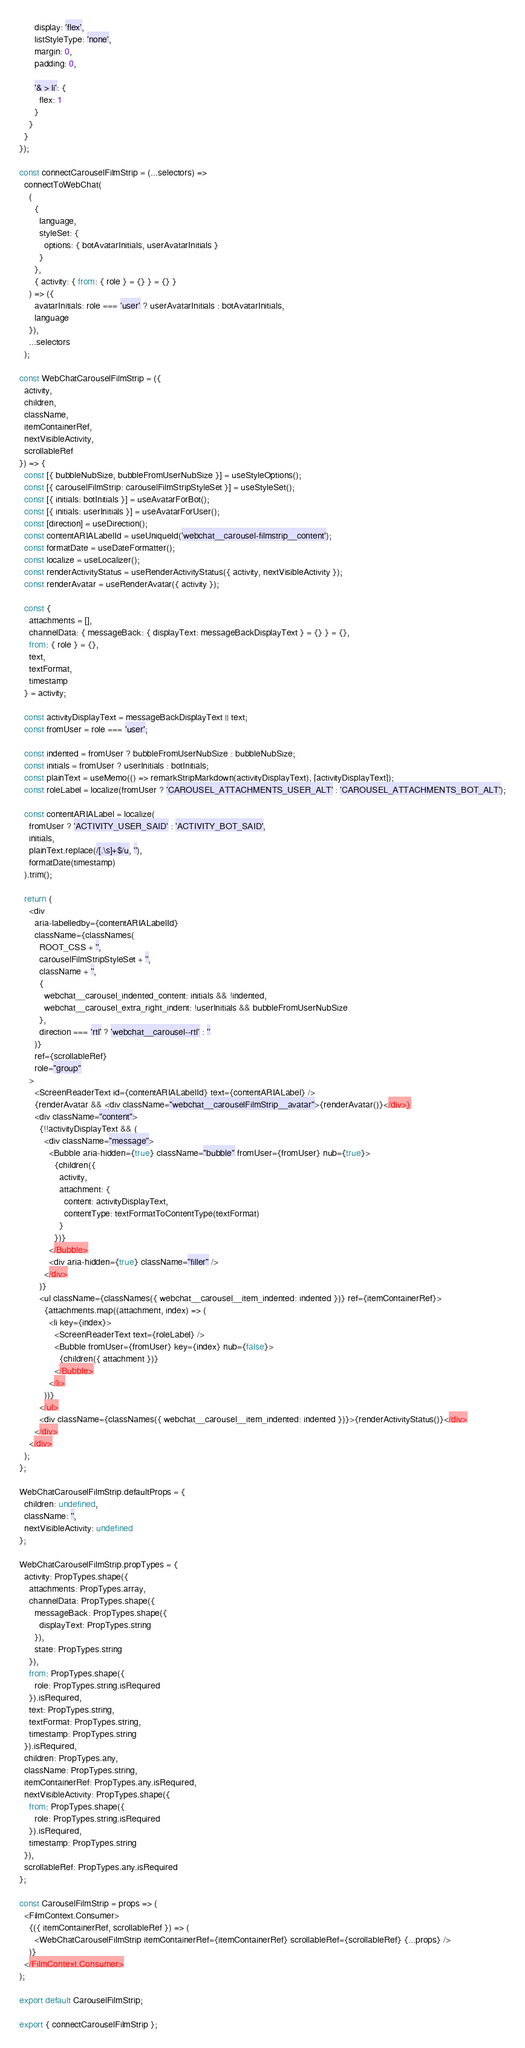<code> <loc_0><loc_0><loc_500><loc_500><_JavaScript_>      display: 'flex',
      listStyleType: 'none',
      margin: 0,
      padding: 0,

      '& > li': {
        flex: 1
      }
    }
  }
});

const connectCarouselFilmStrip = (...selectors) =>
  connectToWebChat(
    (
      {
        language,
        styleSet: {
          options: { botAvatarInitials, userAvatarInitials }
        }
      },
      { activity: { from: { role } = {} } = {} }
    ) => ({
      avatarInitials: role === 'user' ? userAvatarInitials : botAvatarInitials,
      language
    }),
    ...selectors
  );

const WebChatCarouselFilmStrip = ({
  activity,
  children,
  className,
  itemContainerRef,
  nextVisibleActivity,
  scrollableRef
}) => {
  const [{ bubbleNubSize, bubbleFromUserNubSize }] = useStyleOptions();
  const [{ carouselFilmStrip: carouselFilmStripStyleSet }] = useStyleSet();
  const [{ initials: botInitials }] = useAvatarForBot();
  const [{ initials: userInitials }] = useAvatarForUser();
  const [direction] = useDirection();
  const contentARIALabelId = useUniqueId('webchat__carousel-filmstrip__content');
  const formatDate = useDateFormatter();
  const localize = useLocalizer();
  const renderActivityStatus = useRenderActivityStatus({ activity, nextVisibleActivity });
  const renderAvatar = useRenderAvatar({ activity });

  const {
    attachments = [],
    channelData: { messageBack: { displayText: messageBackDisplayText } = {} } = {},
    from: { role } = {},
    text,
    textFormat,
    timestamp
  } = activity;

  const activityDisplayText = messageBackDisplayText || text;
  const fromUser = role === 'user';

  const indented = fromUser ? bubbleFromUserNubSize : bubbleNubSize;
  const initials = fromUser ? userInitials : botInitials;
  const plainText = useMemo(() => remarkStripMarkdown(activityDisplayText), [activityDisplayText]);
  const roleLabel = localize(fromUser ? 'CAROUSEL_ATTACHMENTS_USER_ALT' : 'CAROUSEL_ATTACHMENTS_BOT_ALT');

  const contentARIALabel = localize(
    fromUser ? 'ACTIVITY_USER_SAID' : 'ACTIVITY_BOT_SAID',
    initials,
    plainText.replace(/[.\s]+$/u, ''),
    formatDate(timestamp)
  ).trim();

  return (
    <div
      aria-labelledby={contentARIALabelId}
      className={classNames(
        ROOT_CSS + '',
        carouselFilmStripStyleSet + '',
        className + '',
        {
          webchat__carousel_indented_content: initials && !indented,
          webchat__carousel_extra_right_indent: !userInitials && bubbleFromUserNubSize
        },
        direction === 'rtl' ? 'webchat__carousel--rtl' : ''
      )}
      ref={scrollableRef}
      role="group"
    >
      <ScreenReaderText id={contentARIALabelId} text={contentARIALabel} />
      {renderAvatar && <div className="webchat__carouselFilmStrip__avatar">{renderAvatar()}</div>}
      <div className="content">
        {!!activityDisplayText && (
          <div className="message">
            <Bubble aria-hidden={true} className="bubble" fromUser={fromUser} nub={true}>
              {children({
                activity,
                attachment: {
                  content: activityDisplayText,
                  contentType: textFormatToContentType(textFormat)
                }
              })}
            </Bubble>
            <div aria-hidden={true} className="filler" />
          </div>
        )}
        <ul className={classNames({ webchat__carousel__item_indented: indented })} ref={itemContainerRef}>
          {attachments.map((attachment, index) => (
            <li key={index}>
              <ScreenReaderText text={roleLabel} />
              <Bubble fromUser={fromUser} key={index} nub={false}>
                {children({ attachment })}
              </Bubble>
            </li>
          ))}
        </ul>
        <div className={classNames({ webchat__carousel__item_indented: indented })}>{renderActivityStatus()}</div>
      </div>
    </div>
  );
};

WebChatCarouselFilmStrip.defaultProps = {
  children: undefined,
  className: '',
  nextVisibleActivity: undefined
};

WebChatCarouselFilmStrip.propTypes = {
  activity: PropTypes.shape({
    attachments: PropTypes.array,
    channelData: PropTypes.shape({
      messageBack: PropTypes.shape({
        displayText: PropTypes.string
      }),
      state: PropTypes.string
    }),
    from: PropTypes.shape({
      role: PropTypes.string.isRequired
    }).isRequired,
    text: PropTypes.string,
    textFormat: PropTypes.string,
    timestamp: PropTypes.string
  }).isRequired,
  children: PropTypes.any,
  className: PropTypes.string,
  itemContainerRef: PropTypes.any.isRequired,
  nextVisibleActivity: PropTypes.shape({
    from: PropTypes.shape({
      role: PropTypes.string.isRequired
    }).isRequired,
    timestamp: PropTypes.string
  }),
  scrollableRef: PropTypes.any.isRequired
};

const CarouselFilmStrip = props => (
  <FilmContext.Consumer>
    {({ itemContainerRef, scrollableRef }) => (
      <WebChatCarouselFilmStrip itemContainerRef={itemContainerRef} scrollableRef={scrollableRef} {...props} />
    )}
  </FilmContext.Consumer>
);

export default CarouselFilmStrip;

export { connectCarouselFilmStrip };
</code> 